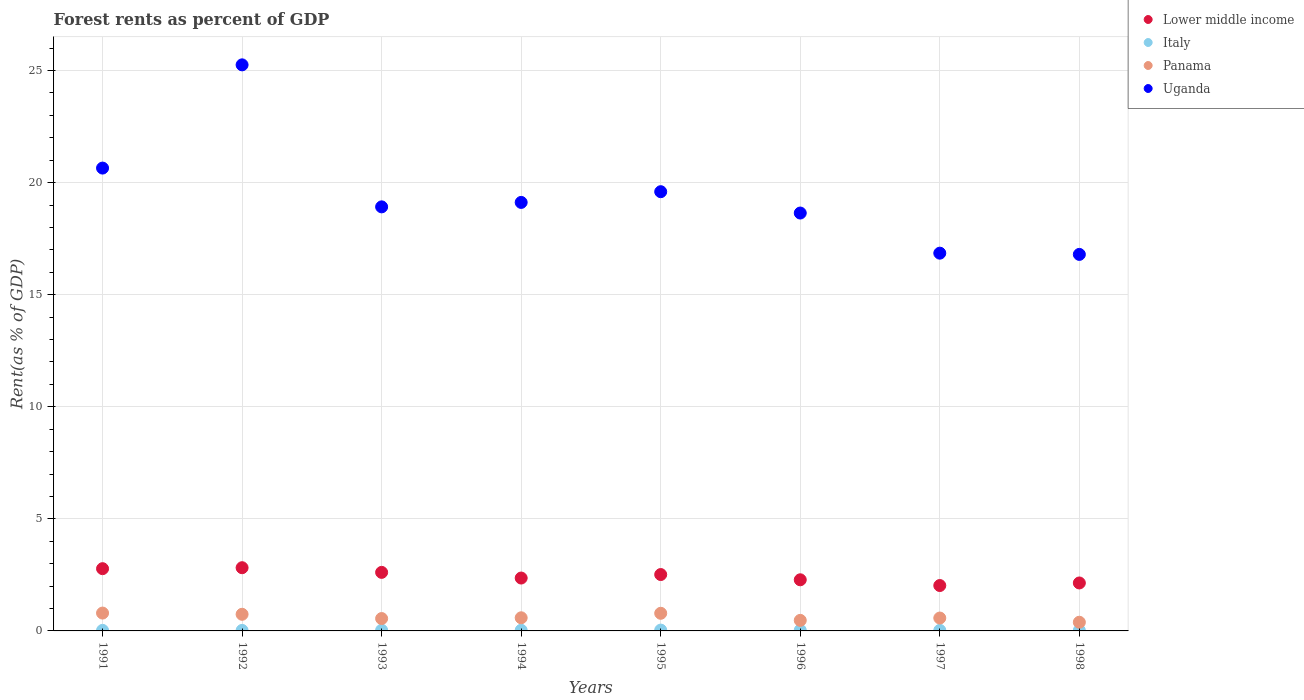Is the number of dotlines equal to the number of legend labels?
Your response must be concise. Yes. What is the forest rent in Uganda in 1993?
Your response must be concise. 18.92. Across all years, what is the maximum forest rent in Lower middle income?
Keep it short and to the point. 2.82. Across all years, what is the minimum forest rent in Uganda?
Your response must be concise. 16.8. What is the total forest rent in Uganda in the graph?
Provide a short and direct response. 155.82. What is the difference between the forest rent in Uganda in 1991 and that in 1993?
Your response must be concise. 1.73. What is the difference between the forest rent in Panama in 1993 and the forest rent in Lower middle income in 1997?
Your answer should be compact. -1.47. What is the average forest rent in Lower middle income per year?
Make the answer very short. 2.44. In the year 1996, what is the difference between the forest rent in Lower middle income and forest rent in Uganda?
Your answer should be very brief. -16.36. In how many years, is the forest rent in Panama greater than 25 %?
Provide a short and direct response. 0. What is the ratio of the forest rent in Uganda in 1996 to that in 1997?
Make the answer very short. 1.11. Is the difference between the forest rent in Lower middle income in 1995 and 1997 greater than the difference between the forest rent in Uganda in 1995 and 1997?
Make the answer very short. No. What is the difference between the highest and the second highest forest rent in Uganda?
Provide a short and direct response. 4.61. What is the difference between the highest and the lowest forest rent in Panama?
Your answer should be compact. 0.41. In how many years, is the forest rent in Uganda greater than the average forest rent in Uganda taken over all years?
Provide a succinct answer. 3. Is the sum of the forest rent in Italy in 1992 and 1995 greater than the maximum forest rent in Panama across all years?
Make the answer very short. No. Is it the case that in every year, the sum of the forest rent in Lower middle income and forest rent in Italy  is greater than the sum of forest rent in Uganda and forest rent in Panama?
Keep it short and to the point. No. Is it the case that in every year, the sum of the forest rent in Italy and forest rent in Uganda  is greater than the forest rent in Panama?
Give a very brief answer. Yes. Does the forest rent in Italy monotonically increase over the years?
Ensure brevity in your answer.  No. Are the values on the major ticks of Y-axis written in scientific E-notation?
Give a very brief answer. No. Does the graph contain grids?
Your answer should be very brief. Yes. Where does the legend appear in the graph?
Provide a short and direct response. Top right. What is the title of the graph?
Keep it short and to the point. Forest rents as percent of GDP. Does "Uzbekistan" appear as one of the legend labels in the graph?
Offer a terse response. No. What is the label or title of the X-axis?
Keep it short and to the point. Years. What is the label or title of the Y-axis?
Offer a terse response. Rent(as % of GDP). What is the Rent(as % of GDP) of Lower middle income in 1991?
Give a very brief answer. 2.78. What is the Rent(as % of GDP) of Italy in 1991?
Give a very brief answer. 0.02. What is the Rent(as % of GDP) in Panama in 1991?
Make the answer very short. 0.8. What is the Rent(as % of GDP) of Uganda in 1991?
Your answer should be very brief. 20.65. What is the Rent(as % of GDP) of Lower middle income in 1992?
Provide a succinct answer. 2.82. What is the Rent(as % of GDP) of Italy in 1992?
Provide a short and direct response. 0.02. What is the Rent(as % of GDP) of Panama in 1992?
Offer a terse response. 0.74. What is the Rent(as % of GDP) of Uganda in 1992?
Your response must be concise. 25.25. What is the Rent(as % of GDP) of Lower middle income in 1993?
Offer a very short reply. 2.61. What is the Rent(as % of GDP) in Italy in 1993?
Make the answer very short. 0.03. What is the Rent(as % of GDP) in Panama in 1993?
Provide a succinct answer. 0.55. What is the Rent(as % of GDP) of Uganda in 1993?
Your answer should be very brief. 18.92. What is the Rent(as % of GDP) of Lower middle income in 1994?
Provide a short and direct response. 2.36. What is the Rent(as % of GDP) in Italy in 1994?
Your answer should be very brief. 0.03. What is the Rent(as % of GDP) in Panama in 1994?
Give a very brief answer. 0.59. What is the Rent(as % of GDP) of Uganda in 1994?
Keep it short and to the point. 19.12. What is the Rent(as % of GDP) in Lower middle income in 1995?
Provide a succinct answer. 2.51. What is the Rent(as % of GDP) of Italy in 1995?
Provide a succinct answer. 0.04. What is the Rent(as % of GDP) of Panama in 1995?
Provide a short and direct response. 0.79. What is the Rent(as % of GDP) of Uganda in 1995?
Give a very brief answer. 19.59. What is the Rent(as % of GDP) in Lower middle income in 1996?
Ensure brevity in your answer.  2.28. What is the Rent(as % of GDP) in Italy in 1996?
Provide a short and direct response. 0.03. What is the Rent(as % of GDP) in Panama in 1996?
Your response must be concise. 0.47. What is the Rent(as % of GDP) in Uganda in 1996?
Offer a very short reply. 18.64. What is the Rent(as % of GDP) in Lower middle income in 1997?
Offer a terse response. 2.02. What is the Rent(as % of GDP) of Italy in 1997?
Provide a succinct answer. 0.03. What is the Rent(as % of GDP) in Panama in 1997?
Ensure brevity in your answer.  0.57. What is the Rent(as % of GDP) in Uganda in 1997?
Provide a succinct answer. 16.85. What is the Rent(as % of GDP) of Lower middle income in 1998?
Offer a very short reply. 2.14. What is the Rent(as % of GDP) of Italy in 1998?
Provide a short and direct response. 0.02. What is the Rent(as % of GDP) of Panama in 1998?
Your answer should be compact. 0.39. What is the Rent(as % of GDP) of Uganda in 1998?
Make the answer very short. 16.8. Across all years, what is the maximum Rent(as % of GDP) in Lower middle income?
Your response must be concise. 2.82. Across all years, what is the maximum Rent(as % of GDP) in Italy?
Your answer should be compact. 0.04. Across all years, what is the maximum Rent(as % of GDP) of Panama?
Provide a succinct answer. 0.8. Across all years, what is the maximum Rent(as % of GDP) in Uganda?
Offer a very short reply. 25.25. Across all years, what is the minimum Rent(as % of GDP) of Lower middle income?
Your answer should be very brief. 2.02. Across all years, what is the minimum Rent(as % of GDP) in Italy?
Offer a terse response. 0.02. Across all years, what is the minimum Rent(as % of GDP) in Panama?
Offer a very short reply. 0.39. Across all years, what is the minimum Rent(as % of GDP) in Uganda?
Provide a succinct answer. 16.8. What is the total Rent(as % of GDP) of Lower middle income in the graph?
Your response must be concise. 19.53. What is the total Rent(as % of GDP) of Italy in the graph?
Your answer should be compact. 0.23. What is the total Rent(as % of GDP) of Panama in the graph?
Give a very brief answer. 4.89. What is the total Rent(as % of GDP) in Uganda in the graph?
Ensure brevity in your answer.  155.82. What is the difference between the Rent(as % of GDP) in Lower middle income in 1991 and that in 1992?
Your answer should be very brief. -0.04. What is the difference between the Rent(as % of GDP) of Italy in 1991 and that in 1992?
Make the answer very short. 0. What is the difference between the Rent(as % of GDP) in Panama in 1991 and that in 1992?
Your answer should be very brief. 0.05. What is the difference between the Rent(as % of GDP) of Uganda in 1991 and that in 1992?
Your answer should be very brief. -4.61. What is the difference between the Rent(as % of GDP) of Lower middle income in 1991 and that in 1993?
Make the answer very short. 0.17. What is the difference between the Rent(as % of GDP) in Italy in 1991 and that in 1993?
Keep it short and to the point. -0.01. What is the difference between the Rent(as % of GDP) in Panama in 1991 and that in 1993?
Your response must be concise. 0.24. What is the difference between the Rent(as % of GDP) in Uganda in 1991 and that in 1993?
Offer a very short reply. 1.73. What is the difference between the Rent(as % of GDP) in Lower middle income in 1991 and that in 1994?
Provide a short and direct response. 0.42. What is the difference between the Rent(as % of GDP) of Italy in 1991 and that in 1994?
Provide a succinct answer. -0.01. What is the difference between the Rent(as % of GDP) of Panama in 1991 and that in 1994?
Your answer should be very brief. 0.21. What is the difference between the Rent(as % of GDP) of Uganda in 1991 and that in 1994?
Give a very brief answer. 1.53. What is the difference between the Rent(as % of GDP) of Lower middle income in 1991 and that in 1995?
Provide a succinct answer. 0.26. What is the difference between the Rent(as % of GDP) of Italy in 1991 and that in 1995?
Offer a very short reply. -0.01. What is the difference between the Rent(as % of GDP) of Panama in 1991 and that in 1995?
Offer a terse response. 0.01. What is the difference between the Rent(as % of GDP) of Uganda in 1991 and that in 1995?
Make the answer very short. 1.05. What is the difference between the Rent(as % of GDP) in Lower middle income in 1991 and that in 1996?
Keep it short and to the point. 0.5. What is the difference between the Rent(as % of GDP) of Italy in 1991 and that in 1996?
Provide a succinct answer. -0.01. What is the difference between the Rent(as % of GDP) in Panama in 1991 and that in 1996?
Provide a short and direct response. 0.33. What is the difference between the Rent(as % of GDP) in Uganda in 1991 and that in 1996?
Keep it short and to the point. 2.01. What is the difference between the Rent(as % of GDP) of Lower middle income in 1991 and that in 1997?
Your answer should be compact. 0.75. What is the difference between the Rent(as % of GDP) of Italy in 1991 and that in 1997?
Offer a very short reply. -0. What is the difference between the Rent(as % of GDP) in Panama in 1991 and that in 1997?
Offer a terse response. 0.22. What is the difference between the Rent(as % of GDP) in Uganda in 1991 and that in 1997?
Offer a terse response. 3.8. What is the difference between the Rent(as % of GDP) in Lower middle income in 1991 and that in 1998?
Your answer should be very brief. 0.64. What is the difference between the Rent(as % of GDP) in Panama in 1991 and that in 1998?
Provide a short and direct response. 0.41. What is the difference between the Rent(as % of GDP) in Uganda in 1991 and that in 1998?
Ensure brevity in your answer.  3.85. What is the difference between the Rent(as % of GDP) of Lower middle income in 1992 and that in 1993?
Make the answer very short. 0.21. What is the difference between the Rent(as % of GDP) of Italy in 1992 and that in 1993?
Ensure brevity in your answer.  -0.01. What is the difference between the Rent(as % of GDP) in Panama in 1992 and that in 1993?
Provide a short and direct response. 0.19. What is the difference between the Rent(as % of GDP) in Uganda in 1992 and that in 1993?
Keep it short and to the point. 6.34. What is the difference between the Rent(as % of GDP) of Lower middle income in 1992 and that in 1994?
Your answer should be very brief. 0.46. What is the difference between the Rent(as % of GDP) in Italy in 1992 and that in 1994?
Keep it short and to the point. -0.01. What is the difference between the Rent(as % of GDP) in Panama in 1992 and that in 1994?
Make the answer very short. 0.16. What is the difference between the Rent(as % of GDP) of Uganda in 1992 and that in 1994?
Your response must be concise. 6.14. What is the difference between the Rent(as % of GDP) of Lower middle income in 1992 and that in 1995?
Provide a short and direct response. 0.3. What is the difference between the Rent(as % of GDP) of Italy in 1992 and that in 1995?
Your answer should be compact. -0.01. What is the difference between the Rent(as % of GDP) of Panama in 1992 and that in 1995?
Give a very brief answer. -0.04. What is the difference between the Rent(as % of GDP) of Uganda in 1992 and that in 1995?
Your response must be concise. 5.66. What is the difference between the Rent(as % of GDP) of Lower middle income in 1992 and that in 1996?
Your answer should be compact. 0.54. What is the difference between the Rent(as % of GDP) of Italy in 1992 and that in 1996?
Offer a very short reply. -0.01. What is the difference between the Rent(as % of GDP) of Panama in 1992 and that in 1996?
Make the answer very short. 0.27. What is the difference between the Rent(as % of GDP) of Uganda in 1992 and that in 1996?
Ensure brevity in your answer.  6.61. What is the difference between the Rent(as % of GDP) in Lower middle income in 1992 and that in 1997?
Your answer should be very brief. 0.79. What is the difference between the Rent(as % of GDP) in Italy in 1992 and that in 1997?
Make the answer very short. -0. What is the difference between the Rent(as % of GDP) of Panama in 1992 and that in 1997?
Your answer should be very brief. 0.17. What is the difference between the Rent(as % of GDP) in Uganda in 1992 and that in 1997?
Provide a short and direct response. 8.4. What is the difference between the Rent(as % of GDP) of Lower middle income in 1992 and that in 1998?
Your answer should be compact. 0.68. What is the difference between the Rent(as % of GDP) in Italy in 1992 and that in 1998?
Provide a short and direct response. -0. What is the difference between the Rent(as % of GDP) in Panama in 1992 and that in 1998?
Ensure brevity in your answer.  0.35. What is the difference between the Rent(as % of GDP) of Uganda in 1992 and that in 1998?
Your response must be concise. 8.46. What is the difference between the Rent(as % of GDP) in Lower middle income in 1993 and that in 1994?
Offer a terse response. 0.25. What is the difference between the Rent(as % of GDP) in Italy in 1993 and that in 1994?
Provide a succinct answer. 0. What is the difference between the Rent(as % of GDP) in Panama in 1993 and that in 1994?
Your response must be concise. -0.03. What is the difference between the Rent(as % of GDP) in Uganda in 1993 and that in 1994?
Ensure brevity in your answer.  -0.2. What is the difference between the Rent(as % of GDP) in Lower middle income in 1993 and that in 1995?
Ensure brevity in your answer.  0.1. What is the difference between the Rent(as % of GDP) of Italy in 1993 and that in 1995?
Keep it short and to the point. -0.01. What is the difference between the Rent(as % of GDP) in Panama in 1993 and that in 1995?
Your answer should be compact. -0.23. What is the difference between the Rent(as % of GDP) of Uganda in 1993 and that in 1995?
Make the answer very short. -0.68. What is the difference between the Rent(as % of GDP) in Lower middle income in 1993 and that in 1996?
Make the answer very short. 0.33. What is the difference between the Rent(as % of GDP) in Italy in 1993 and that in 1996?
Make the answer very short. 0. What is the difference between the Rent(as % of GDP) of Panama in 1993 and that in 1996?
Keep it short and to the point. 0.08. What is the difference between the Rent(as % of GDP) in Uganda in 1993 and that in 1996?
Offer a terse response. 0.28. What is the difference between the Rent(as % of GDP) of Lower middle income in 1993 and that in 1997?
Provide a succinct answer. 0.59. What is the difference between the Rent(as % of GDP) in Italy in 1993 and that in 1997?
Provide a short and direct response. 0.01. What is the difference between the Rent(as % of GDP) of Panama in 1993 and that in 1997?
Your answer should be compact. -0.02. What is the difference between the Rent(as % of GDP) of Uganda in 1993 and that in 1997?
Your response must be concise. 2.07. What is the difference between the Rent(as % of GDP) of Lower middle income in 1993 and that in 1998?
Offer a very short reply. 0.47. What is the difference between the Rent(as % of GDP) in Italy in 1993 and that in 1998?
Your answer should be compact. 0.01. What is the difference between the Rent(as % of GDP) in Panama in 1993 and that in 1998?
Your answer should be very brief. 0.16. What is the difference between the Rent(as % of GDP) in Uganda in 1993 and that in 1998?
Provide a short and direct response. 2.12. What is the difference between the Rent(as % of GDP) of Lower middle income in 1994 and that in 1995?
Offer a very short reply. -0.16. What is the difference between the Rent(as % of GDP) in Italy in 1994 and that in 1995?
Offer a terse response. -0.01. What is the difference between the Rent(as % of GDP) in Panama in 1994 and that in 1995?
Provide a succinct answer. -0.2. What is the difference between the Rent(as % of GDP) in Uganda in 1994 and that in 1995?
Offer a terse response. -0.48. What is the difference between the Rent(as % of GDP) of Lower middle income in 1994 and that in 1996?
Keep it short and to the point. 0.08. What is the difference between the Rent(as % of GDP) of Italy in 1994 and that in 1996?
Keep it short and to the point. -0. What is the difference between the Rent(as % of GDP) in Panama in 1994 and that in 1996?
Provide a succinct answer. 0.12. What is the difference between the Rent(as % of GDP) of Uganda in 1994 and that in 1996?
Provide a short and direct response. 0.47. What is the difference between the Rent(as % of GDP) of Lower middle income in 1994 and that in 1997?
Your answer should be very brief. 0.33. What is the difference between the Rent(as % of GDP) of Italy in 1994 and that in 1997?
Provide a short and direct response. 0. What is the difference between the Rent(as % of GDP) of Panama in 1994 and that in 1997?
Offer a terse response. 0.01. What is the difference between the Rent(as % of GDP) of Uganda in 1994 and that in 1997?
Provide a succinct answer. 2.26. What is the difference between the Rent(as % of GDP) in Lower middle income in 1994 and that in 1998?
Ensure brevity in your answer.  0.22. What is the difference between the Rent(as % of GDP) of Italy in 1994 and that in 1998?
Keep it short and to the point. 0.01. What is the difference between the Rent(as % of GDP) of Panama in 1994 and that in 1998?
Provide a short and direct response. 0.2. What is the difference between the Rent(as % of GDP) of Uganda in 1994 and that in 1998?
Make the answer very short. 2.32. What is the difference between the Rent(as % of GDP) in Lower middle income in 1995 and that in 1996?
Your answer should be very brief. 0.23. What is the difference between the Rent(as % of GDP) of Italy in 1995 and that in 1996?
Your answer should be very brief. 0.01. What is the difference between the Rent(as % of GDP) of Panama in 1995 and that in 1996?
Offer a terse response. 0.32. What is the difference between the Rent(as % of GDP) in Uganda in 1995 and that in 1996?
Offer a terse response. 0.95. What is the difference between the Rent(as % of GDP) in Lower middle income in 1995 and that in 1997?
Your answer should be compact. 0.49. What is the difference between the Rent(as % of GDP) in Italy in 1995 and that in 1997?
Offer a very short reply. 0.01. What is the difference between the Rent(as % of GDP) of Panama in 1995 and that in 1997?
Give a very brief answer. 0.21. What is the difference between the Rent(as % of GDP) of Uganda in 1995 and that in 1997?
Ensure brevity in your answer.  2.74. What is the difference between the Rent(as % of GDP) in Lower middle income in 1995 and that in 1998?
Your response must be concise. 0.38. What is the difference between the Rent(as % of GDP) in Italy in 1995 and that in 1998?
Your answer should be compact. 0.01. What is the difference between the Rent(as % of GDP) of Panama in 1995 and that in 1998?
Provide a short and direct response. 0.4. What is the difference between the Rent(as % of GDP) of Uganda in 1995 and that in 1998?
Provide a succinct answer. 2.8. What is the difference between the Rent(as % of GDP) in Lower middle income in 1996 and that in 1997?
Ensure brevity in your answer.  0.26. What is the difference between the Rent(as % of GDP) of Italy in 1996 and that in 1997?
Your answer should be compact. 0.01. What is the difference between the Rent(as % of GDP) of Panama in 1996 and that in 1997?
Make the answer very short. -0.1. What is the difference between the Rent(as % of GDP) in Uganda in 1996 and that in 1997?
Your response must be concise. 1.79. What is the difference between the Rent(as % of GDP) in Lower middle income in 1996 and that in 1998?
Keep it short and to the point. 0.14. What is the difference between the Rent(as % of GDP) in Italy in 1996 and that in 1998?
Keep it short and to the point. 0.01. What is the difference between the Rent(as % of GDP) in Panama in 1996 and that in 1998?
Make the answer very short. 0.08. What is the difference between the Rent(as % of GDP) of Uganda in 1996 and that in 1998?
Offer a terse response. 1.85. What is the difference between the Rent(as % of GDP) of Lower middle income in 1997 and that in 1998?
Offer a terse response. -0.11. What is the difference between the Rent(as % of GDP) in Italy in 1997 and that in 1998?
Your answer should be compact. 0. What is the difference between the Rent(as % of GDP) in Panama in 1997 and that in 1998?
Keep it short and to the point. 0.19. What is the difference between the Rent(as % of GDP) in Uganda in 1997 and that in 1998?
Your response must be concise. 0.06. What is the difference between the Rent(as % of GDP) in Lower middle income in 1991 and the Rent(as % of GDP) in Italy in 1992?
Give a very brief answer. 2.75. What is the difference between the Rent(as % of GDP) of Lower middle income in 1991 and the Rent(as % of GDP) of Panama in 1992?
Provide a short and direct response. 2.04. What is the difference between the Rent(as % of GDP) in Lower middle income in 1991 and the Rent(as % of GDP) in Uganda in 1992?
Make the answer very short. -22.48. What is the difference between the Rent(as % of GDP) of Italy in 1991 and the Rent(as % of GDP) of Panama in 1992?
Ensure brevity in your answer.  -0.72. What is the difference between the Rent(as % of GDP) of Italy in 1991 and the Rent(as % of GDP) of Uganda in 1992?
Keep it short and to the point. -25.23. What is the difference between the Rent(as % of GDP) in Panama in 1991 and the Rent(as % of GDP) in Uganda in 1992?
Provide a succinct answer. -24.46. What is the difference between the Rent(as % of GDP) in Lower middle income in 1991 and the Rent(as % of GDP) in Italy in 1993?
Keep it short and to the point. 2.75. What is the difference between the Rent(as % of GDP) in Lower middle income in 1991 and the Rent(as % of GDP) in Panama in 1993?
Offer a terse response. 2.23. What is the difference between the Rent(as % of GDP) of Lower middle income in 1991 and the Rent(as % of GDP) of Uganda in 1993?
Provide a succinct answer. -16.14. What is the difference between the Rent(as % of GDP) in Italy in 1991 and the Rent(as % of GDP) in Panama in 1993?
Your response must be concise. -0.53. What is the difference between the Rent(as % of GDP) of Italy in 1991 and the Rent(as % of GDP) of Uganda in 1993?
Offer a very short reply. -18.89. What is the difference between the Rent(as % of GDP) in Panama in 1991 and the Rent(as % of GDP) in Uganda in 1993?
Your answer should be compact. -18.12. What is the difference between the Rent(as % of GDP) in Lower middle income in 1991 and the Rent(as % of GDP) in Italy in 1994?
Ensure brevity in your answer.  2.75. What is the difference between the Rent(as % of GDP) in Lower middle income in 1991 and the Rent(as % of GDP) in Panama in 1994?
Your answer should be compact. 2.19. What is the difference between the Rent(as % of GDP) of Lower middle income in 1991 and the Rent(as % of GDP) of Uganda in 1994?
Provide a succinct answer. -16.34. What is the difference between the Rent(as % of GDP) in Italy in 1991 and the Rent(as % of GDP) in Panama in 1994?
Ensure brevity in your answer.  -0.56. What is the difference between the Rent(as % of GDP) in Italy in 1991 and the Rent(as % of GDP) in Uganda in 1994?
Provide a short and direct response. -19.09. What is the difference between the Rent(as % of GDP) in Panama in 1991 and the Rent(as % of GDP) in Uganda in 1994?
Offer a very short reply. -18.32. What is the difference between the Rent(as % of GDP) of Lower middle income in 1991 and the Rent(as % of GDP) of Italy in 1995?
Your answer should be very brief. 2.74. What is the difference between the Rent(as % of GDP) of Lower middle income in 1991 and the Rent(as % of GDP) of Panama in 1995?
Make the answer very short. 1.99. What is the difference between the Rent(as % of GDP) of Lower middle income in 1991 and the Rent(as % of GDP) of Uganda in 1995?
Offer a very short reply. -16.82. What is the difference between the Rent(as % of GDP) in Italy in 1991 and the Rent(as % of GDP) in Panama in 1995?
Give a very brief answer. -0.76. What is the difference between the Rent(as % of GDP) in Italy in 1991 and the Rent(as % of GDP) in Uganda in 1995?
Your answer should be compact. -19.57. What is the difference between the Rent(as % of GDP) of Panama in 1991 and the Rent(as % of GDP) of Uganda in 1995?
Your answer should be compact. -18.8. What is the difference between the Rent(as % of GDP) in Lower middle income in 1991 and the Rent(as % of GDP) in Italy in 1996?
Make the answer very short. 2.75. What is the difference between the Rent(as % of GDP) of Lower middle income in 1991 and the Rent(as % of GDP) of Panama in 1996?
Make the answer very short. 2.31. What is the difference between the Rent(as % of GDP) of Lower middle income in 1991 and the Rent(as % of GDP) of Uganda in 1996?
Offer a terse response. -15.87. What is the difference between the Rent(as % of GDP) of Italy in 1991 and the Rent(as % of GDP) of Panama in 1996?
Give a very brief answer. -0.45. What is the difference between the Rent(as % of GDP) in Italy in 1991 and the Rent(as % of GDP) in Uganda in 1996?
Your answer should be very brief. -18.62. What is the difference between the Rent(as % of GDP) of Panama in 1991 and the Rent(as % of GDP) of Uganda in 1996?
Provide a short and direct response. -17.85. What is the difference between the Rent(as % of GDP) in Lower middle income in 1991 and the Rent(as % of GDP) in Italy in 1997?
Ensure brevity in your answer.  2.75. What is the difference between the Rent(as % of GDP) of Lower middle income in 1991 and the Rent(as % of GDP) of Panama in 1997?
Keep it short and to the point. 2.2. What is the difference between the Rent(as % of GDP) of Lower middle income in 1991 and the Rent(as % of GDP) of Uganda in 1997?
Provide a short and direct response. -14.08. What is the difference between the Rent(as % of GDP) of Italy in 1991 and the Rent(as % of GDP) of Panama in 1997?
Provide a short and direct response. -0.55. What is the difference between the Rent(as % of GDP) of Italy in 1991 and the Rent(as % of GDP) of Uganda in 1997?
Your response must be concise. -16.83. What is the difference between the Rent(as % of GDP) of Panama in 1991 and the Rent(as % of GDP) of Uganda in 1997?
Your response must be concise. -16.06. What is the difference between the Rent(as % of GDP) in Lower middle income in 1991 and the Rent(as % of GDP) in Italy in 1998?
Ensure brevity in your answer.  2.75. What is the difference between the Rent(as % of GDP) in Lower middle income in 1991 and the Rent(as % of GDP) in Panama in 1998?
Give a very brief answer. 2.39. What is the difference between the Rent(as % of GDP) in Lower middle income in 1991 and the Rent(as % of GDP) in Uganda in 1998?
Your answer should be very brief. -14.02. What is the difference between the Rent(as % of GDP) in Italy in 1991 and the Rent(as % of GDP) in Panama in 1998?
Give a very brief answer. -0.36. What is the difference between the Rent(as % of GDP) of Italy in 1991 and the Rent(as % of GDP) of Uganda in 1998?
Offer a terse response. -16.77. What is the difference between the Rent(as % of GDP) of Panama in 1991 and the Rent(as % of GDP) of Uganda in 1998?
Your answer should be very brief. -16. What is the difference between the Rent(as % of GDP) of Lower middle income in 1992 and the Rent(as % of GDP) of Italy in 1993?
Provide a succinct answer. 2.79. What is the difference between the Rent(as % of GDP) in Lower middle income in 1992 and the Rent(as % of GDP) in Panama in 1993?
Ensure brevity in your answer.  2.27. What is the difference between the Rent(as % of GDP) of Lower middle income in 1992 and the Rent(as % of GDP) of Uganda in 1993?
Provide a short and direct response. -16.1. What is the difference between the Rent(as % of GDP) in Italy in 1992 and the Rent(as % of GDP) in Panama in 1993?
Offer a very short reply. -0.53. What is the difference between the Rent(as % of GDP) in Italy in 1992 and the Rent(as % of GDP) in Uganda in 1993?
Offer a terse response. -18.9. What is the difference between the Rent(as % of GDP) of Panama in 1992 and the Rent(as % of GDP) of Uganda in 1993?
Keep it short and to the point. -18.18. What is the difference between the Rent(as % of GDP) of Lower middle income in 1992 and the Rent(as % of GDP) of Italy in 1994?
Your response must be concise. 2.79. What is the difference between the Rent(as % of GDP) of Lower middle income in 1992 and the Rent(as % of GDP) of Panama in 1994?
Offer a terse response. 2.23. What is the difference between the Rent(as % of GDP) in Lower middle income in 1992 and the Rent(as % of GDP) in Uganda in 1994?
Make the answer very short. -16.3. What is the difference between the Rent(as % of GDP) in Italy in 1992 and the Rent(as % of GDP) in Panama in 1994?
Your answer should be very brief. -0.56. What is the difference between the Rent(as % of GDP) of Italy in 1992 and the Rent(as % of GDP) of Uganda in 1994?
Your answer should be compact. -19.09. What is the difference between the Rent(as % of GDP) of Panama in 1992 and the Rent(as % of GDP) of Uganda in 1994?
Give a very brief answer. -18.37. What is the difference between the Rent(as % of GDP) of Lower middle income in 1992 and the Rent(as % of GDP) of Italy in 1995?
Offer a very short reply. 2.78. What is the difference between the Rent(as % of GDP) of Lower middle income in 1992 and the Rent(as % of GDP) of Panama in 1995?
Your answer should be very brief. 2.03. What is the difference between the Rent(as % of GDP) in Lower middle income in 1992 and the Rent(as % of GDP) in Uganda in 1995?
Provide a short and direct response. -16.77. What is the difference between the Rent(as % of GDP) in Italy in 1992 and the Rent(as % of GDP) in Panama in 1995?
Provide a succinct answer. -0.76. What is the difference between the Rent(as % of GDP) in Italy in 1992 and the Rent(as % of GDP) in Uganda in 1995?
Keep it short and to the point. -19.57. What is the difference between the Rent(as % of GDP) of Panama in 1992 and the Rent(as % of GDP) of Uganda in 1995?
Provide a short and direct response. -18.85. What is the difference between the Rent(as % of GDP) of Lower middle income in 1992 and the Rent(as % of GDP) of Italy in 1996?
Provide a short and direct response. 2.79. What is the difference between the Rent(as % of GDP) of Lower middle income in 1992 and the Rent(as % of GDP) of Panama in 1996?
Offer a terse response. 2.35. What is the difference between the Rent(as % of GDP) in Lower middle income in 1992 and the Rent(as % of GDP) in Uganda in 1996?
Keep it short and to the point. -15.82. What is the difference between the Rent(as % of GDP) of Italy in 1992 and the Rent(as % of GDP) of Panama in 1996?
Provide a short and direct response. -0.45. What is the difference between the Rent(as % of GDP) in Italy in 1992 and the Rent(as % of GDP) in Uganda in 1996?
Provide a short and direct response. -18.62. What is the difference between the Rent(as % of GDP) in Panama in 1992 and the Rent(as % of GDP) in Uganda in 1996?
Keep it short and to the point. -17.9. What is the difference between the Rent(as % of GDP) in Lower middle income in 1992 and the Rent(as % of GDP) in Italy in 1997?
Your answer should be compact. 2.79. What is the difference between the Rent(as % of GDP) in Lower middle income in 1992 and the Rent(as % of GDP) in Panama in 1997?
Give a very brief answer. 2.25. What is the difference between the Rent(as % of GDP) of Lower middle income in 1992 and the Rent(as % of GDP) of Uganda in 1997?
Give a very brief answer. -14.03. What is the difference between the Rent(as % of GDP) of Italy in 1992 and the Rent(as % of GDP) of Panama in 1997?
Your answer should be compact. -0.55. What is the difference between the Rent(as % of GDP) in Italy in 1992 and the Rent(as % of GDP) in Uganda in 1997?
Make the answer very short. -16.83. What is the difference between the Rent(as % of GDP) in Panama in 1992 and the Rent(as % of GDP) in Uganda in 1997?
Provide a succinct answer. -16.11. What is the difference between the Rent(as % of GDP) in Lower middle income in 1992 and the Rent(as % of GDP) in Italy in 1998?
Your answer should be very brief. 2.8. What is the difference between the Rent(as % of GDP) in Lower middle income in 1992 and the Rent(as % of GDP) in Panama in 1998?
Keep it short and to the point. 2.43. What is the difference between the Rent(as % of GDP) in Lower middle income in 1992 and the Rent(as % of GDP) in Uganda in 1998?
Provide a short and direct response. -13.98. What is the difference between the Rent(as % of GDP) in Italy in 1992 and the Rent(as % of GDP) in Panama in 1998?
Keep it short and to the point. -0.36. What is the difference between the Rent(as % of GDP) in Italy in 1992 and the Rent(as % of GDP) in Uganda in 1998?
Give a very brief answer. -16.77. What is the difference between the Rent(as % of GDP) in Panama in 1992 and the Rent(as % of GDP) in Uganda in 1998?
Provide a short and direct response. -16.06. What is the difference between the Rent(as % of GDP) of Lower middle income in 1993 and the Rent(as % of GDP) of Italy in 1994?
Your answer should be very brief. 2.58. What is the difference between the Rent(as % of GDP) in Lower middle income in 1993 and the Rent(as % of GDP) in Panama in 1994?
Offer a very short reply. 2.03. What is the difference between the Rent(as % of GDP) of Lower middle income in 1993 and the Rent(as % of GDP) of Uganda in 1994?
Offer a very short reply. -16.5. What is the difference between the Rent(as % of GDP) of Italy in 1993 and the Rent(as % of GDP) of Panama in 1994?
Offer a very short reply. -0.55. What is the difference between the Rent(as % of GDP) of Italy in 1993 and the Rent(as % of GDP) of Uganda in 1994?
Make the answer very short. -19.08. What is the difference between the Rent(as % of GDP) of Panama in 1993 and the Rent(as % of GDP) of Uganda in 1994?
Provide a succinct answer. -18.56. What is the difference between the Rent(as % of GDP) in Lower middle income in 1993 and the Rent(as % of GDP) in Italy in 1995?
Give a very brief answer. 2.58. What is the difference between the Rent(as % of GDP) in Lower middle income in 1993 and the Rent(as % of GDP) in Panama in 1995?
Ensure brevity in your answer.  1.83. What is the difference between the Rent(as % of GDP) of Lower middle income in 1993 and the Rent(as % of GDP) of Uganda in 1995?
Provide a succinct answer. -16.98. What is the difference between the Rent(as % of GDP) in Italy in 1993 and the Rent(as % of GDP) in Panama in 1995?
Provide a short and direct response. -0.75. What is the difference between the Rent(as % of GDP) in Italy in 1993 and the Rent(as % of GDP) in Uganda in 1995?
Your answer should be compact. -19.56. What is the difference between the Rent(as % of GDP) of Panama in 1993 and the Rent(as % of GDP) of Uganda in 1995?
Provide a succinct answer. -19.04. What is the difference between the Rent(as % of GDP) of Lower middle income in 1993 and the Rent(as % of GDP) of Italy in 1996?
Your answer should be compact. 2.58. What is the difference between the Rent(as % of GDP) in Lower middle income in 1993 and the Rent(as % of GDP) in Panama in 1996?
Your answer should be compact. 2.14. What is the difference between the Rent(as % of GDP) of Lower middle income in 1993 and the Rent(as % of GDP) of Uganda in 1996?
Give a very brief answer. -16.03. What is the difference between the Rent(as % of GDP) in Italy in 1993 and the Rent(as % of GDP) in Panama in 1996?
Your answer should be very brief. -0.44. What is the difference between the Rent(as % of GDP) of Italy in 1993 and the Rent(as % of GDP) of Uganda in 1996?
Ensure brevity in your answer.  -18.61. What is the difference between the Rent(as % of GDP) of Panama in 1993 and the Rent(as % of GDP) of Uganda in 1996?
Keep it short and to the point. -18.09. What is the difference between the Rent(as % of GDP) in Lower middle income in 1993 and the Rent(as % of GDP) in Italy in 1997?
Keep it short and to the point. 2.59. What is the difference between the Rent(as % of GDP) of Lower middle income in 1993 and the Rent(as % of GDP) of Panama in 1997?
Your answer should be very brief. 2.04. What is the difference between the Rent(as % of GDP) in Lower middle income in 1993 and the Rent(as % of GDP) in Uganda in 1997?
Ensure brevity in your answer.  -14.24. What is the difference between the Rent(as % of GDP) of Italy in 1993 and the Rent(as % of GDP) of Panama in 1997?
Your response must be concise. -0.54. What is the difference between the Rent(as % of GDP) of Italy in 1993 and the Rent(as % of GDP) of Uganda in 1997?
Give a very brief answer. -16.82. What is the difference between the Rent(as % of GDP) in Panama in 1993 and the Rent(as % of GDP) in Uganda in 1997?
Offer a terse response. -16.3. What is the difference between the Rent(as % of GDP) in Lower middle income in 1993 and the Rent(as % of GDP) in Italy in 1998?
Ensure brevity in your answer.  2.59. What is the difference between the Rent(as % of GDP) of Lower middle income in 1993 and the Rent(as % of GDP) of Panama in 1998?
Provide a succinct answer. 2.22. What is the difference between the Rent(as % of GDP) of Lower middle income in 1993 and the Rent(as % of GDP) of Uganda in 1998?
Make the answer very short. -14.19. What is the difference between the Rent(as % of GDP) of Italy in 1993 and the Rent(as % of GDP) of Panama in 1998?
Provide a short and direct response. -0.36. What is the difference between the Rent(as % of GDP) in Italy in 1993 and the Rent(as % of GDP) in Uganda in 1998?
Your response must be concise. -16.77. What is the difference between the Rent(as % of GDP) in Panama in 1993 and the Rent(as % of GDP) in Uganda in 1998?
Offer a terse response. -16.25. What is the difference between the Rent(as % of GDP) in Lower middle income in 1994 and the Rent(as % of GDP) in Italy in 1995?
Make the answer very short. 2.32. What is the difference between the Rent(as % of GDP) of Lower middle income in 1994 and the Rent(as % of GDP) of Panama in 1995?
Offer a terse response. 1.57. What is the difference between the Rent(as % of GDP) of Lower middle income in 1994 and the Rent(as % of GDP) of Uganda in 1995?
Your answer should be very brief. -17.24. What is the difference between the Rent(as % of GDP) in Italy in 1994 and the Rent(as % of GDP) in Panama in 1995?
Your answer should be compact. -0.76. What is the difference between the Rent(as % of GDP) of Italy in 1994 and the Rent(as % of GDP) of Uganda in 1995?
Provide a short and direct response. -19.56. What is the difference between the Rent(as % of GDP) of Panama in 1994 and the Rent(as % of GDP) of Uganda in 1995?
Provide a succinct answer. -19.01. What is the difference between the Rent(as % of GDP) of Lower middle income in 1994 and the Rent(as % of GDP) of Italy in 1996?
Ensure brevity in your answer.  2.33. What is the difference between the Rent(as % of GDP) of Lower middle income in 1994 and the Rent(as % of GDP) of Panama in 1996?
Your response must be concise. 1.89. What is the difference between the Rent(as % of GDP) in Lower middle income in 1994 and the Rent(as % of GDP) in Uganda in 1996?
Offer a very short reply. -16.28. What is the difference between the Rent(as % of GDP) of Italy in 1994 and the Rent(as % of GDP) of Panama in 1996?
Give a very brief answer. -0.44. What is the difference between the Rent(as % of GDP) of Italy in 1994 and the Rent(as % of GDP) of Uganda in 1996?
Make the answer very short. -18.61. What is the difference between the Rent(as % of GDP) in Panama in 1994 and the Rent(as % of GDP) in Uganda in 1996?
Your answer should be very brief. -18.06. What is the difference between the Rent(as % of GDP) of Lower middle income in 1994 and the Rent(as % of GDP) of Italy in 1997?
Make the answer very short. 2.33. What is the difference between the Rent(as % of GDP) in Lower middle income in 1994 and the Rent(as % of GDP) in Panama in 1997?
Provide a short and direct response. 1.78. What is the difference between the Rent(as % of GDP) of Lower middle income in 1994 and the Rent(as % of GDP) of Uganda in 1997?
Your response must be concise. -14.49. What is the difference between the Rent(as % of GDP) of Italy in 1994 and the Rent(as % of GDP) of Panama in 1997?
Offer a terse response. -0.55. What is the difference between the Rent(as % of GDP) in Italy in 1994 and the Rent(as % of GDP) in Uganda in 1997?
Make the answer very short. -16.82. What is the difference between the Rent(as % of GDP) in Panama in 1994 and the Rent(as % of GDP) in Uganda in 1997?
Ensure brevity in your answer.  -16.27. What is the difference between the Rent(as % of GDP) of Lower middle income in 1994 and the Rent(as % of GDP) of Italy in 1998?
Make the answer very short. 2.34. What is the difference between the Rent(as % of GDP) in Lower middle income in 1994 and the Rent(as % of GDP) in Panama in 1998?
Offer a very short reply. 1.97. What is the difference between the Rent(as % of GDP) in Lower middle income in 1994 and the Rent(as % of GDP) in Uganda in 1998?
Ensure brevity in your answer.  -14.44. What is the difference between the Rent(as % of GDP) in Italy in 1994 and the Rent(as % of GDP) in Panama in 1998?
Give a very brief answer. -0.36. What is the difference between the Rent(as % of GDP) of Italy in 1994 and the Rent(as % of GDP) of Uganda in 1998?
Keep it short and to the point. -16.77. What is the difference between the Rent(as % of GDP) in Panama in 1994 and the Rent(as % of GDP) in Uganda in 1998?
Give a very brief answer. -16.21. What is the difference between the Rent(as % of GDP) of Lower middle income in 1995 and the Rent(as % of GDP) of Italy in 1996?
Offer a very short reply. 2.48. What is the difference between the Rent(as % of GDP) in Lower middle income in 1995 and the Rent(as % of GDP) in Panama in 1996?
Ensure brevity in your answer.  2.04. What is the difference between the Rent(as % of GDP) of Lower middle income in 1995 and the Rent(as % of GDP) of Uganda in 1996?
Offer a very short reply. -16.13. What is the difference between the Rent(as % of GDP) of Italy in 1995 and the Rent(as % of GDP) of Panama in 1996?
Ensure brevity in your answer.  -0.43. What is the difference between the Rent(as % of GDP) of Italy in 1995 and the Rent(as % of GDP) of Uganda in 1996?
Ensure brevity in your answer.  -18.61. What is the difference between the Rent(as % of GDP) in Panama in 1995 and the Rent(as % of GDP) in Uganda in 1996?
Your answer should be very brief. -17.86. What is the difference between the Rent(as % of GDP) in Lower middle income in 1995 and the Rent(as % of GDP) in Italy in 1997?
Make the answer very short. 2.49. What is the difference between the Rent(as % of GDP) of Lower middle income in 1995 and the Rent(as % of GDP) of Panama in 1997?
Your answer should be very brief. 1.94. What is the difference between the Rent(as % of GDP) of Lower middle income in 1995 and the Rent(as % of GDP) of Uganda in 1997?
Your answer should be compact. -14.34. What is the difference between the Rent(as % of GDP) in Italy in 1995 and the Rent(as % of GDP) in Panama in 1997?
Offer a terse response. -0.54. What is the difference between the Rent(as % of GDP) of Italy in 1995 and the Rent(as % of GDP) of Uganda in 1997?
Keep it short and to the point. -16.82. What is the difference between the Rent(as % of GDP) in Panama in 1995 and the Rent(as % of GDP) in Uganda in 1997?
Make the answer very short. -16.07. What is the difference between the Rent(as % of GDP) of Lower middle income in 1995 and the Rent(as % of GDP) of Italy in 1998?
Make the answer very short. 2.49. What is the difference between the Rent(as % of GDP) of Lower middle income in 1995 and the Rent(as % of GDP) of Panama in 1998?
Give a very brief answer. 2.13. What is the difference between the Rent(as % of GDP) in Lower middle income in 1995 and the Rent(as % of GDP) in Uganda in 1998?
Keep it short and to the point. -14.28. What is the difference between the Rent(as % of GDP) of Italy in 1995 and the Rent(as % of GDP) of Panama in 1998?
Give a very brief answer. -0.35. What is the difference between the Rent(as % of GDP) in Italy in 1995 and the Rent(as % of GDP) in Uganda in 1998?
Offer a terse response. -16.76. What is the difference between the Rent(as % of GDP) in Panama in 1995 and the Rent(as % of GDP) in Uganda in 1998?
Provide a short and direct response. -16.01. What is the difference between the Rent(as % of GDP) of Lower middle income in 1996 and the Rent(as % of GDP) of Italy in 1997?
Give a very brief answer. 2.26. What is the difference between the Rent(as % of GDP) of Lower middle income in 1996 and the Rent(as % of GDP) of Panama in 1997?
Provide a succinct answer. 1.71. What is the difference between the Rent(as % of GDP) in Lower middle income in 1996 and the Rent(as % of GDP) in Uganda in 1997?
Provide a succinct answer. -14.57. What is the difference between the Rent(as % of GDP) in Italy in 1996 and the Rent(as % of GDP) in Panama in 1997?
Give a very brief answer. -0.54. What is the difference between the Rent(as % of GDP) of Italy in 1996 and the Rent(as % of GDP) of Uganda in 1997?
Your response must be concise. -16.82. What is the difference between the Rent(as % of GDP) of Panama in 1996 and the Rent(as % of GDP) of Uganda in 1997?
Offer a terse response. -16.38. What is the difference between the Rent(as % of GDP) in Lower middle income in 1996 and the Rent(as % of GDP) in Italy in 1998?
Ensure brevity in your answer.  2.26. What is the difference between the Rent(as % of GDP) in Lower middle income in 1996 and the Rent(as % of GDP) in Panama in 1998?
Your answer should be compact. 1.89. What is the difference between the Rent(as % of GDP) of Lower middle income in 1996 and the Rent(as % of GDP) of Uganda in 1998?
Your answer should be compact. -14.52. What is the difference between the Rent(as % of GDP) of Italy in 1996 and the Rent(as % of GDP) of Panama in 1998?
Make the answer very short. -0.36. What is the difference between the Rent(as % of GDP) of Italy in 1996 and the Rent(as % of GDP) of Uganda in 1998?
Offer a terse response. -16.77. What is the difference between the Rent(as % of GDP) in Panama in 1996 and the Rent(as % of GDP) in Uganda in 1998?
Make the answer very short. -16.33. What is the difference between the Rent(as % of GDP) of Lower middle income in 1997 and the Rent(as % of GDP) of Italy in 1998?
Provide a short and direct response. 2. What is the difference between the Rent(as % of GDP) in Lower middle income in 1997 and the Rent(as % of GDP) in Panama in 1998?
Ensure brevity in your answer.  1.64. What is the difference between the Rent(as % of GDP) in Lower middle income in 1997 and the Rent(as % of GDP) in Uganda in 1998?
Keep it short and to the point. -14.77. What is the difference between the Rent(as % of GDP) of Italy in 1997 and the Rent(as % of GDP) of Panama in 1998?
Provide a succinct answer. -0.36. What is the difference between the Rent(as % of GDP) of Italy in 1997 and the Rent(as % of GDP) of Uganda in 1998?
Make the answer very short. -16.77. What is the difference between the Rent(as % of GDP) of Panama in 1997 and the Rent(as % of GDP) of Uganda in 1998?
Your answer should be very brief. -16.22. What is the average Rent(as % of GDP) of Lower middle income per year?
Your answer should be compact. 2.44. What is the average Rent(as % of GDP) of Italy per year?
Your response must be concise. 0.03. What is the average Rent(as % of GDP) of Panama per year?
Your response must be concise. 0.61. What is the average Rent(as % of GDP) in Uganda per year?
Ensure brevity in your answer.  19.48. In the year 1991, what is the difference between the Rent(as % of GDP) in Lower middle income and Rent(as % of GDP) in Italy?
Keep it short and to the point. 2.75. In the year 1991, what is the difference between the Rent(as % of GDP) of Lower middle income and Rent(as % of GDP) of Panama?
Your answer should be compact. 1.98. In the year 1991, what is the difference between the Rent(as % of GDP) in Lower middle income and Rent(as % of GDP) in Uganda?
Keep it short and to the point. -17.87. In the year 1991, what is the difference between the Rent(as % of GDP) in Italy and Rent(as % of GDP) in Panama?
Your answer should be very brief. -0.77. In the year 1991, what is the difference between the Rent(as % of GDP) in Italy and Rent(as % of GDP) in Uganda?
Give a very brief answer. -20.62. In the year 1991, what is the difference between the Rent(as % of GDP) of Panama and Rent(as % of GDP) of Uganda?
Your response must be concise. -19.85. In the year 1992, what is the difference between the Rent(as % of GDP) in Lower middle income and Rent(as % of GDP) in Italy?
Provide a short and direct response. 2.8. In the year 1992, what is the difference between the Rent(as % of GDP) of Lower middle income and Rent(as % of GDP) of Panama?
Your response must be concise. 2.08. In the year 1992, what is the difference between the Rent(as % of GDP) of Lower middle income and Rent(as % of GDP) of Uganda?
Your answer should be very brief. -22.43. In the year 1992, what is the difference between the Rent(as % of GDP) in Italy and Rent(as % of GDP) in Panama?
Offer a very short reply. -0.72. In the year 1992, what is the difference between the Rent(as % of GDP) in Italy and Rent(as % of GDP) in Uganda?
Give a very brief answer. -25.23. In the year 1992, what is the difference between the Rent(as % of GDP) in Panama and Rent(as % of GDP) in Uganda?
Offer a terse response. -24.51. In the year 1993, what is the difference between the Rent(as % of GDP) in Lower middle income and Rent(as % of GDP) in Italy?
Keep it short and to the point. 2.58. In the year 1993, what is the difference between the Rent(as % of GDP) in Lower middle income and Rent(as % of GDP) in Panama?
Offer a terse response. 2.06. In the year 1993, what is the difference between the Rent(as % of GDP) in Lower middle income and Rent(as % of GDP) in Uganda?
Your answer should be very brief. -16.31. In the year 1993, what is the difference between the Rent(as % of GDP) in Italy and Rent(as % of GDP) in Panama?
Your response must be concise. -0.52. In the year 1993, what is the difference between the Rent(as % of GDP) in Italy and Rent(as % of GDP) in Uganda?
Provide a succinct answer. -18.89. In the year 1993, what is the difference between the Rent(as % of GDP) in Panama and Rent(as % of GDP) in Uganda?
Give a very brief answer. -18.37. In the year 1994, what is the difference between the Rent(as % of GDP) in Lower middle income and Rent(as % of GDP) in Italy?
Offer a terse response. 2.33. In the year 1994, what is the difference between the Rent(as % of GDP) in Lower middle income and Rent(as % of GDP) in Panama?
Your response must be concise. 1.77. In the year 1994, what is the difference between the Rent(as % of GDP) of Lower middle income and Rent(as % of GDP) of Uganda?
Make the answer very short. -16.76. In the year 1994, what is the difference between the Rent(as % of GDP) in Italy and Rent(as % of GDP) in Panama?
Ensure brevity in your answer.  -0.56. In the year 1994, what is the difference between the Rent(as % of GDP) in Italy and Rent(as % of GDP) in Uganda?
Offer a very short reply. -19.09. In the year 1994, what is the difference between the Rent(as % of GDP) of Panama and Rent(as % of GDP) of Uganda?
Make the answer very short. -18.53. In the year 1995, what is the difference between the Rent(as % of GDP) in Lower middle income and Rent(as % of GDP) in Italy?
Offer a terse response. 2.48. In the year 1995, what is the difference between the Rent(as % of GDP) in Lower middle income and Rent(as % of GDP) in Panama?
Your answer should be compact. 1.73. In the year 1995, what is the difference between the Rent(as % of GDP) in Lower middle income and Rent(as % of GDP) in Uganda?
Ensure brevity in your answer.  -17.08. In the year 1995, what is the difference between the Rent(as % of GDP) of Italy and Rent(as % of GDP) of Panama?
Your answer should be compact. -0.75. In the year 1995, what is the difference between the Rent(as % of GDP) in Italy and Rent(as % of GDP) in Uganda?
Keep it short and to the point. -19.56. In the year 1995, what is the difference between the Rent(as % of GDP) in Panama and Rent(as % of GDP) in Uganda?
Your answer should be very brief. -18.81. In the year 1996, what is the difference between the Rent(as % of GDP) of Lower middle income and Rent(as % of GDP) of Italy?
Offer a terse response. 2.25. In the year 1996, what is the difference between the Rent(as % of GDP) in Lower middle income and Rent(as % of GDP) in Panama?
Your response must be concise. 1.81. In the year 1996, what is the difference between the Rent(as % of GDP) in Lower middle income and Rent(as % of GDP) in Uganda?
Provide a succinct answer. -16.36. In the year 1996, what is the difference between the Rent(as % of GDP) of Italy and Rent(as % of GDP) of Panama?
Offer a very short reply. -0.44. In the year 1996, what is the difference between the Rent(as % of GDP) of Italy and Rent(as % of GDP) of Uganda?
Your answer should be very brief. -18.61. In the year 1996, what is the difference between the Rent(as % of GDP) of Panama and Rent(as % of GDP) of Uganda?
Your answer should be very brief. -18.17. In the year 1997, what is the difference between the Rent(as % of GDP) in Lower middle income and Rent(as % of GDP) in Italy?
Keep it short and to the point. 2. In the year 1997, what is the difference between the Rent(as % of GDP) of Lower middle income and Rent(as % of GDP) of Panama?
Make the answer very short. 1.45. In the year 1997, what is the difference between the Rent(as % of GDP) of Lower middle income and Rent(as % of GDP) of Uganda?
Provide a short and direct response. -14.83. In the year 1997, what is the difference between the Rent(as % of GDP) of Italy and Rent(as % of GDP) of Panama?
Your answer should be very brief. -0.55. In the year 1997, what is the difference between the Rent(as % of GDP) in Italy and Rent(as % of GDP) in Uganda?
Your answer should be compact. -16.83. In the year 1997, what is the difference between the Rent(as % of GDP) of Panama and Rent(as % of GDP) of Uganda?
Provide a succinct answer. -16.28. In the year 1998, what is the difference between the Rent(as % of GDP) in Lower middle income and Rent(as % of GDP) in Italy?
Provide a short and direct response. 2.12. In the year 1998, what is the difference between the Rent(as % of GDP) of Lower middle income and Rent(as % of GDP) of Panama?
Make the answer very short. 1.75. In the year 1998, what is the difference between the Rent(as % of GDP) in Lower middle income and Rent(as % of GDP) in Uganda?
Your response must be concise. -14.66. In the year 1998, what is the difference between the Rent(as % of GDP) in Italy and Rent(as % of GDP) in Panama?
Your response must be concise. -0.36. In the year 1998, what is the difference between the Rent(as % of GDP) in Italy and Rent(as % of GDP) in Uganda?
Your response must be concise. -16.77. In the year 1998, what is the difference between the Rent(as % of GDP) in Panama and Rent(as % of GDP) in Uganda?
Ensure brevity in your answer.  -16.41. What is the ratio of the Rent(as % of GDP) in Italy in 1991 to that in 1992?
Your answer should be very brief. 1.07. What is the ratio of the Rent(as % of GDP) of Panama in 1991 to that in 1992?
Offer a terse response. 1.07. What is the ratio of the Rent(as % of GDP) of Uganda in 1991 to that in 1992?
Your answer should be very brief. 0.82. What is the ratio of the Rent(as % of GDP) in Lower middle income in 1991 to that in 1993?
Offer a terse response. 1.06. What is the ratio of the Rent(as % of GDP) of Italy in 1991 to that in 1993?
Your response must be concise. 0.78. What is the ratio of the Rent(as % of GDP) in Panama in 1991 to that in 1993?
Give a very brief answer. 1.44. What is the ratio of the Rent(as % of GDP) of Uganda in 1991 to that in 1993?
Ensure brevity in your answer.  1.09. What is the ratio of the Rent(as % of GDP) in Lower middle income in 1991 to that in 1994?
Ensure brevity in your answer.  1.18. What is the ratio of the Rent(as % of GDP) in Italy in 1991 to that in 1994?
Provide a short and direct response. 0.83. What is the ratio of the Rent(as % of GDP) in Panama in 1991 to that in 1994?
Your answer should be compact. 1.36. What is the ratio of the Rent(as % of GDP) in Uganda in 1991 to that in 1994?
Your response must be concise. 1.08. What is the ratio of the Rent(as % of GDP) of Lower middle income in 1991 to that in 1995?
Give a very brief answer. 1.1. What is the ratio of the Rent(as % of GDP) in Italy in 1991 to that in 1995?
Keep it short and to the point. 0.67. What is the ratio of the Rent(as % of GDP) in Panama in 1991 to that in 1995?
Provide a short and direct response. 1.01. What is the ratio of the Rent(as % of GDP) of Uganda in 1991 to that in 1995?
Your response must be concise. 1.05. What is the ratio of the Rent(as % of GDP) in Lower middle income in 1991 to that in 1996?
Offer a terse response. 1.22. What is the ratio of the Rent(as % of GDP) in Italy in 1991 to that in 1996?
Your answer should be compact. 0.79. What is the ratio of the Rent(as % of GDP) of Panama in 1991 to that in 1996?
Provide a short and direct response. 1.69. What is the ratio of the Rent(as % of GDP) of Uganda in 1991 to that in 1996?
Your answer should be very brief. 1.11. What is the ratio of the Rent(as % of GDP) in Lower middle income in 1991 to that in 1997?
Offer a terse response. 1.37. What is the ratio of the Rent(as % of GDP) of Italy in 1991 to that in 1997?
Provide a short and direct response. 0.95. What is the ratio of the Rent(as % of GDP) in Panama in 1991 to that in 1997?
Keep it short and to the point. 1.39. What is the ratio of the Rent(as % of GDP) in Uganda in 1991 to that in 1997?
Provide a succinct answer. 1.23. What is the ratio of the Rent(as % of GDP) of Lower middle income in 1991 to that in 1998?
Your response must be concise. 1.3. What is the ratio of the Rent(as % of GDP) in Italy in 1991 to that in 1998?
Make the answer very short. 1.04. What is the ratio of the Rent(as % of GDP) of Panama in 1991 to that in 1998?
Your answer should be compact. 2.06. What is the ratio of the Rent(as % of GDP) of Uganda in 1991 to that in 1998?
Offer a very short reply. 1.23. What is the ratio of the Rent(as % of GDP) in Lower middle income in 1992 to that in 1993?
Ensure brevity in your answer.  1.08. What is the ratio of the Rent(as % of GDP) in Italy in 1992 to that in 1993?
Your answer should be very brief. 0.72. What is the ratio of the Rent(as % of GDP) in Panama in 1992 to that in 1993?
Make the answer very short. 1.34. What is the ratio of the Rent(as % of GDP) in Uganda in 1992 to that in 1993?
Keep it short and to the point. 1.33. What is the ratio of the Rent(as % of GDP) of Lower middle income in 1992 to that in 1994?
Your answer should be very brief. 1.2. What is the ratio of the Rent(as % of GDP) of Italy in 1992 to that in 1994?
Ensure brevity in your answer.  0.78. What is the ratio of the Rent(as % of GDP) of Panama in 1992 to that in 1994?
Your response must be concise. 1.27. What is the ratio of the Rent(as % of GDP) in Uganda in 1992 to that in 1994?
Make the answer very short. 1.32. What is the ratio of the Rent(as % of GDP) of Lower middle income in 1992 to that in 1995?
Ensure brevity in your answer.  1.12. What is the ratio of the Rent(as % of GDP) in Italy in 1992 to that in 1995?
Your answer should be very brief. 0.62. What is the ratio of the Rent(as % of GDP) of Panama in 1992 to that in 1995?
Your answer should be compact. 0.94. What is the ratio of the Rent(as % of GDP) of Uganda in 1992 to that in 1995?
Keep it short and to the point. 1.29. What is the ratio of the Rent(as % of GDP) in Lower middle income in 1992 to that in 1996?
Provide a succinct answer. 1.24. What is the ratio of the Rent(as % of GDP) in Italy in 1992 to that in 1996?
Make the answer very short. 0.74. What is the ratio of the Rent(as % of GDP) of Panama in 1992 to that in 1996?
Your answer should be compact. 1.58. What is the ratio of the Rent(as % of GDP) of Uganda in 1992 to that in 1996?
Your answer should be very brief. 1.35. What is the ratio of the Rent(as % of GDP) in Lower middle income in 1992 to that in 1997?
Ensure brevity in your answer.  1.39. What is the ratio of the Rent(as % of GDP) of Italy in 1992 to that in 1997?
Provide a short and direct response. 0.88. What is the ratio of the Rent(as % of GDP) in Panama in 1992 to that in 1997?
Provide a succinct answer. 1.29. What is the ratio of the Rent(as % of GDP) in Uganda in 1992 to that in 1997?
Provide a short and direct response. 1.5. What is the ratio of the Rent(as % of GDP) of Lower middle income in 1992 to that in 1998?
Your answer should be very brief. 1.32. What is the ratio of the Rent(as % of GDP) in Italy in 1992 to that in 1998?
Your answer should be very brief. 0.97. What is the ratio of the Rent(as % of GDP) of Panama in 1992 to that in 1998?
Your response must be concise. 1.92. What is the ratio of the Rent(as % of GDP) in Uganda in 1992 to that in 1998?
Ensure brevity in your answer.  1.5. What is the ratio of the Rent(as % of GDP) in Lower middle income in 1993 to that in 1994?
Provide a short and direct response. 1.11. What is the ratio of the Rent(as % of GDP) of Italy in 1993 to that in 1994?
Your answer should be very brief. 1.07. What is the ratio of the Rent(as % of GDP) in Panama in 1993 to that in 1994?
Your answer should be very brief. 0.94. What is the ratio of the Rent(as % of GDP) in Lower middle income in 1993 to that in 1995?
Offer a terse response. 1.04. What is the ratio of the Rent(as % of GDP) in Italy in 1993 to that in 1995?
Offer a very short reply. 0.86. What is the ratio of the Rent(as % of GDP) in Panama in 1993 to that in 1995?
Offer a terse response. 0.7. What is the ratio of the Rent(as % of GDP) in Uganda in 1993 to that in 1995?
Keep it short and to the point. 0.97. What is the ratio of the Rent(as % of GDP) of Lower middle income in 1993 to that in 1996?
Make the answer very short. 1.15. What is the ratio of the Rent(as % of GDP) in Italy in 1993 to that in 1996?
Provide a succinct answer. 1.02. What is the ratio of the Rent(as % of GDP) in Panama in 1993 to that in 1996?
Ensure brevity in your answer.  1.17. What is the ratio of the Rent(as % of GDP) in Uganda in 1993 to that in 1996?
Your response must be concise. 1.01. What is the ratio of the Rent(as % of GDP) of Lower middle income in 1993 to that in 1997?
Provide a short and direct response. 1.29. What is the ratio of the Rent(as % of GDP) of Italy in 1993 to that in 1997?
Provide a short and direct response. 1.22. What is the ratio of the Rent(as % of GDP) in Panama in 1993 to that in 1997?
Keep it short and to the point. 0.96. What is the ratio of the Rent(as % of GDP) of Uganda in 1993 to that in 1997?
Ensure brevity in your answer.  1.12. What is the ratio of the Rent(as % of GDP) of Lower middle income in 1993 to that in 1998?
Make the answer very short. 1.22. What is the ratio of the Rent(as % of GDP) in Italy in 1993 to that in 1998?
Keep it short and to the point. 1.35. What is the ratio of the Rent(as % of GDP) of Panama in 1993 to that in 1998?
Your response must be concise. 1.43. What is the ratio of the Rent(as % of GDP) in Uganda in 1993 to that in 1998?
Offer a very short reply. 1.13. What is the ratio of the Rent(as % of GDP) of Lower middle income in 1994 to that in 1995?
Your response must be concise. 0.94. What is the ratio of the Rent(as % of GDP) of Italy in 1994 to that in 1995?
Ensure brevity in your answer.  0.81. What is the ratio of the Rent(as % of GDP) of Panama in 1994 to that in 1995?
Provide a short and direct response. 0.74. What is the ratio of the Rent(as % of GDP) of Uganda in 1994 to that in 1995?
Offer a very short reply. 0.98. What is the ratio of the Rent(as % of GDP) in Lower middle income in 1994 to that in 1996?
Make the answer very short. 1.03. What is the ratio of the Rent(as % of GDP) of Italy in 1994 to that in 1996?
Keep it short and to the point. 0.95. What is the ratio of the Rent(as % of GDP) in Panama in 1994 to that in 1996?
Offer a terse response. 1.24. What is the ratio of the Rent(as % of GDP) in Uganda in 1994 to that in 1996?
Keep it short and to the point. 1.03. What is the ratio of the Rent(as % of GDP) in Lower middle income in 1994 to that in 1997?
Your response must be concise. 1.17. What is the ratio of the Rent(as % of GDP) in Italy in 1994 to that in 1997?
Ensure brevity in your answer.  1.14. What is the ratio of the Rent(as % of GDP) of Panama in 1994 to that in 1997?
Give a very brief answer. 1.02. What is the ratio of the Rent(as % of GDP) of Uganda in 1994 to that in 1997?
Your answer should be compact. 1.13. What is the ratio of the Rent(as % of GDP) in Lower middle income in 1994 to that in 1998?
Give a very brief answer. 1.1. What is the ratio of the Rent(as % of GDP) of Italy in 1994 to that in 1998?
Make the answer very short. 1.26. What is the ratio of the Rent(as % of GDP) in Panama in 1994 to that in 1998?
Provide a short and direct response. 1.51. What is the ratio of the Rent(as % of GDP) of Uganda in 1994 to that in 1998?
Give a very brief answer. 1.14. What is the ratio of the Rent(as % of GDP) of Lower middle income in 1995 to that in 1996?
Your response must be concise. 1.1. What is the ratio of the Rent(as % of GDP) of Italy in 1995 to that in 1996?
Your answer should be very brief. 1.19. What is the ratio of the Rent(as % of GDP) of Panama in 1995 to that in 1996?
Provide a short and direct response. 1.67. What is the ratio of the Rent(as % of GDP) of Uganda in 1995 to that in 1996?
Ensure brevity in your answer.  1.05. What is the ratio of the Rent(as % of GDP) of Lower middle income in 1995 to that in 1997?
Ensure brevity in your answer.  1.24. What is the ratio of the Rent(as % of GDP) of Italy in 1995 to that in 1997?
Give a very brief answer. 1.42. What is the ratio of the Rent(as % of GDP) in Panama in 1995 to that in 1997?
Your answer should be compact. 1.37. What is the ratio of the Rent(as % of GDP) of Uganda in 1995 to that in 1997?
Offer a terse response. 1.16. What is the ratio of the Rent(as % of GDP) of Lower middle income in 1995 to that in 1998?
Give a very brief answer. 1.18. What is the ratio of the Rent(as % of GDP) of Italy in 1995 to that in 1998?
Your answer should be compact. 1.56. What is the ratio of the Rent(as % of GDP) of Panama in 1995 to that in 1998?
Your response must be concise. 2.03. What is the ratio of the Rent(as % of GDP) of Uganda in 1995 to that in 1998?
Provide a succinct answer. 1.17. What is the ratio of the Rent(as % of GDP) in Lower middle income in 1996 to that in 1997?
Provide a short and direct response. 1.13. What is the ratio of the Rent(as % of GDP) of Italy in 1996 to that in 1997?
Ensure brevity in your answer.  1.19. What is the ratio of the Rent(as % of GDP) of Panama in 1996 to that in 1997?
Ensure brevity in your answer.  0.82. What is the ratio of the Rent(as % of GDP) of Uganda in 1996 to that in 1997?
Offer a very short reply. 1.11. What is the ratio of the Rent(as % of GDP) of Lower middle income in 1996 to that in 1998?
Keep it short and to the point. 1.07. What is the ratio of the Rent(as % of GDP) in Italy in 1996 to that in 1998?
Ensure brevity in your answer.  1.32. What is the ratio of the Rent(as % of GDP) in Panama in 1996 to that in 1998?
Provide a short and direct response. 1.22. What is the ratio of the Rent(as % of GDP) in Uganda in 1996 to that in 1998?
Offer a terse response. 1.11. What is the ratio of the Rent(as % of GDP) in Lower middle income in 1997 to that in 1998?
Your answer should be very brief. 0.95. What is the ratio of the Rent(as % of GDP) of Italy in 1997 to that in 1998?
Offer a terse response. 1.1. What is the ratio of the Rent(as % of GDP) in Panama in 1997 to that in 1998?
Provide a succinct answer. 1.49. What is the ratio of the Rent(as % of GDP) of Uganda in 1997 to that in 1998?
Your answer should be very brief. 1. What is the difference between the highest and the second highest Rent(as % of GDP) of Lower middle income?
Offer a terse response. 0.04. What is the difference between the highest and the second highest Rent(as % of GDP) in Italy?
Your response must be concise. 0.01. What is the difference between the highest and the second highest Rent(as % of GDP) of Panama?
Your answer should be very brief. 0.01. What is the difference between the highest and the second highest Rent(as % of GDP) of Uganda?
Keep it short and to the point. 4.61. What is the difference between the highest and the lowest Rent(as % of GDP) of Lower middle income?
Make the answer very short. 0.79. What is the difference between the highest and the lowest Rent(as % of GDP) of Italy?
Your answer should be very brief. 0.01. What is the difference between the highest and the lowest Rent(as % of GDP) in Panama?
Provide a succinct answer. 0.41. What is the difference between the highest and the lowest Rent(as % of GDP) of Uganda?
Make the answer very short. 8.46. 